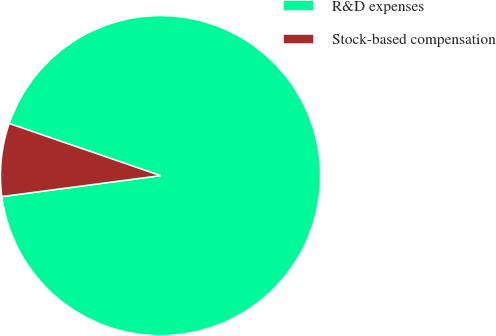Convert chart. <chart><loc_0><loc_0><loc_500><loc_500><pie_chart><fcel>R&D expenses<fcel>Stock-based compensation<nl><fcel>92.63%<fcel>7.37%<nl></chart> 